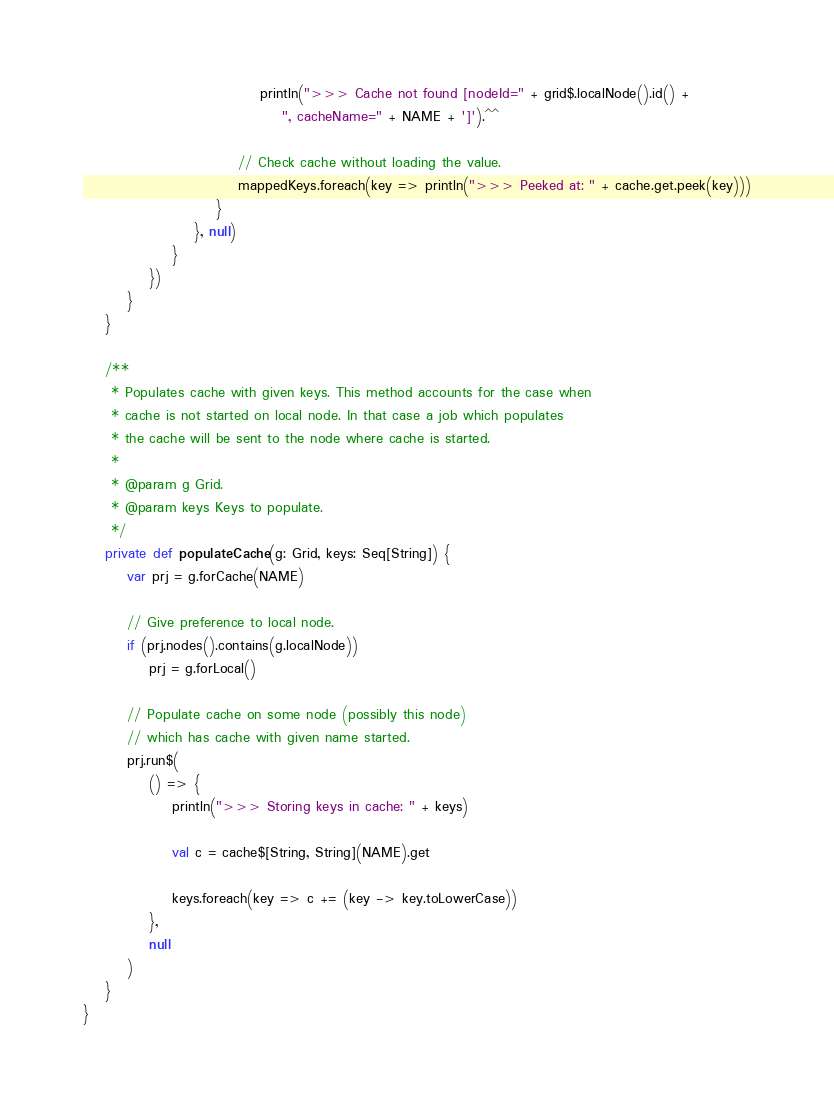<code> <loc_0><loc_0><loc_500><loc_500><_Scala_>                                println(">>> Cache not found [nodeId=" + grid$.localNode().id() +
                                    ", cacheName=" + NAME + ']').^^

                            // Check cache without loading the value.
                            mappedKeys.foreach(key => println(">>> Peeked at: " + cache.get.peek(key)))
                        }
                    }, null)
                }
            })
        }
    }

    /**
     * Populates cache with given keys. This method accounts for the case when
     * cache is not started on local node. In that case a job which populates
     * the cache will be sent to the node where cache is started.
     *
     * @param g Grid.
     * @param keys Keys to populate.
     */
    private def populateCache(g: Grid, keys: Seq[String]) {
        var prj = g.forCache(NAME)

        // Give preference to local node.
        if (prj.nodes().contains(g.localNode))
            prj = g.forLocal()

        // Populate cache on some node (possibly this node)
        // which has cache with given name started.
        prj.run$(
            () => {
                println(">>> Storing keys in cache: " + keys)

                val c = cache$[String, String](NAME).get

                keys.foreach(key => c += (key -> key.toLowerCase))
            },
            null
        )
    }
}
</code> 